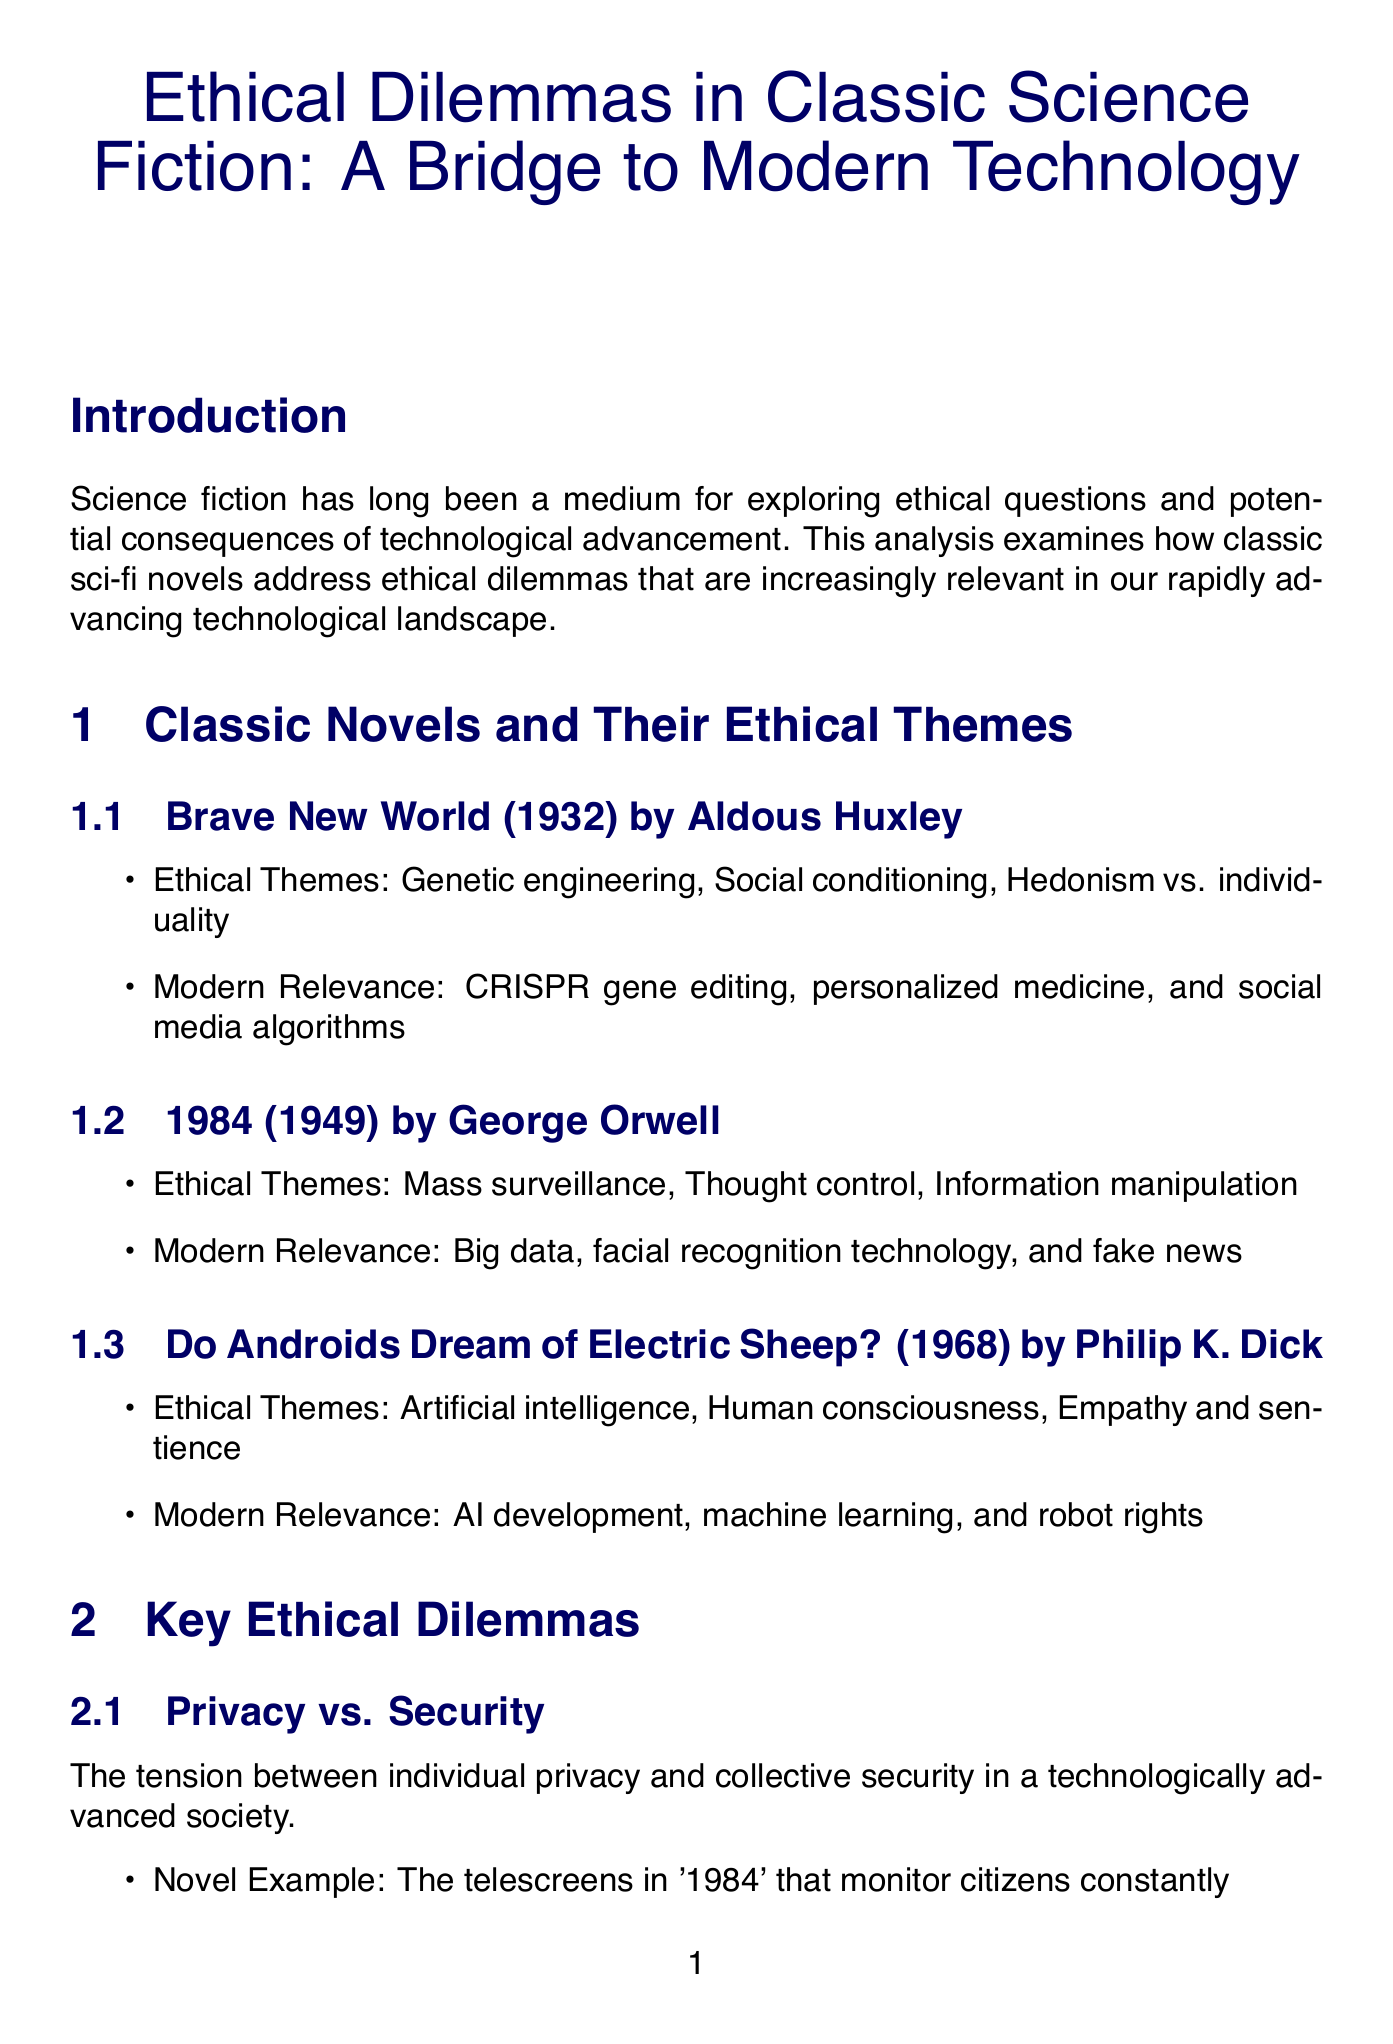What is the title of the report? The title of the report is provided in the first section, which outlines the focus of the analysis.
Answer: Ethical Dilemmas in Classic Science Fiction: A Bridge to Modern Technology Who is the author of "1984"? The document lists the author of "1984" as part of the classic novels section.
Answer: George Orwell What year was "Do Androids Dream of Electric Sheep?" published? The year of publication is mentioned next to the novel title in the classic novels section.
Answer: 1968 Which ethical theme is associated with "Brave New World"? The document highlights several ethical themes associated with the novel in its analysis section.
Answer: Genetic engineering What is a modern parallel to the treatment of androids in "Do Androids Dream of Electric Sheep?" The document specifies discussions about AI personhood and legal rights for advanced AI systems as a modern parallel.
Answer: Discussions about AI personhood and legal rights for advanced AI systems What philosophical perspective questions the nature of reality and memory? The document provides examples of philosophical perspectives and associates one with the themes explored in the novel.
Answer: Existentialism What is an ethical concern related to Brain-Computer Interfaces? The document lists multiple ethical concerns in the section about modern technological advancements.
Answer: Privacy of thoughts Name one ethical dilemma discussed in the report. The report highlights various ethical dilemmas, and naming one requires referencing the key ethical dilemmas section.
Answer: Privacy vs. Security 